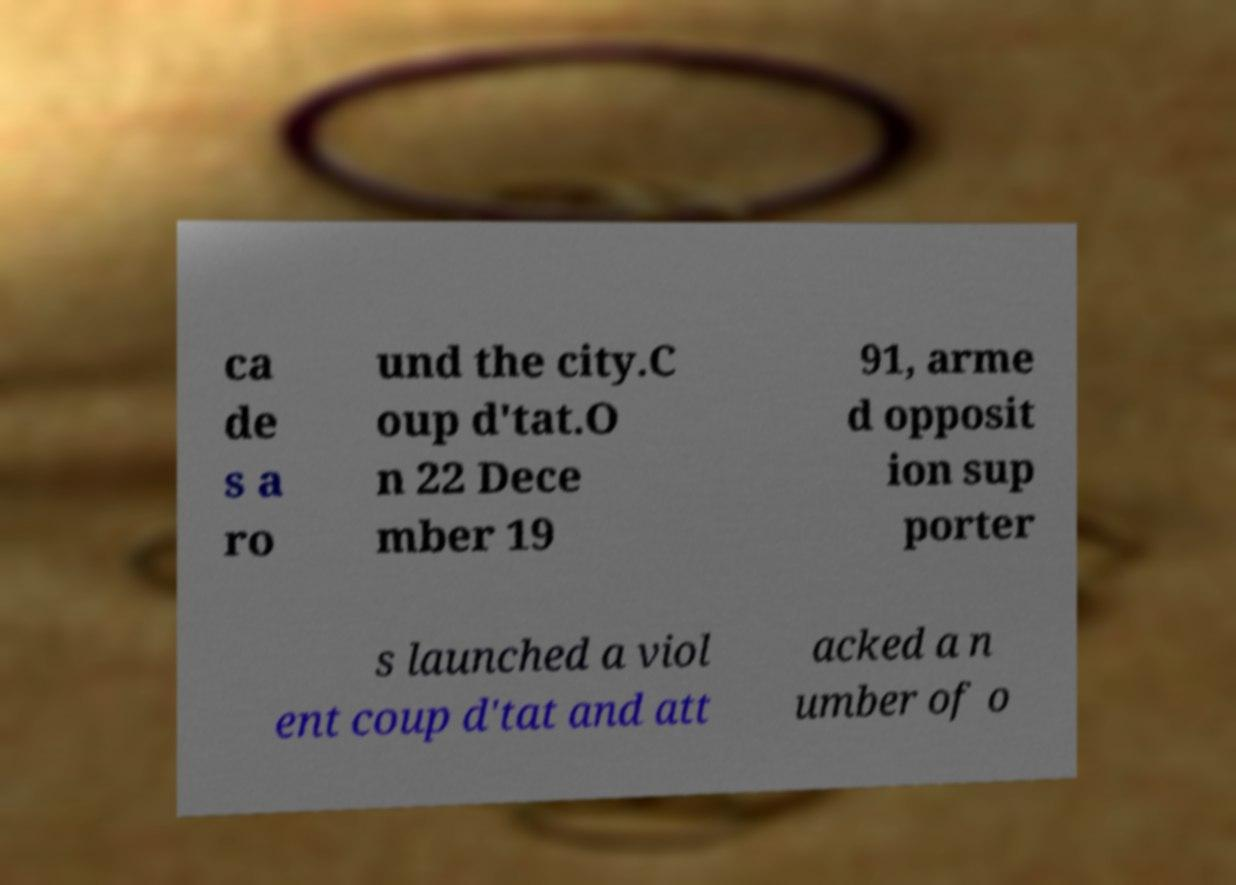Please identify and transcribe the text found in this image. ca de s a ro und the city.C oup d'tat.O n 22 Dece mber 19 91, arme d opposit ion sup porter s launched a viol ent coup d'tat and att acked a n umber of o 